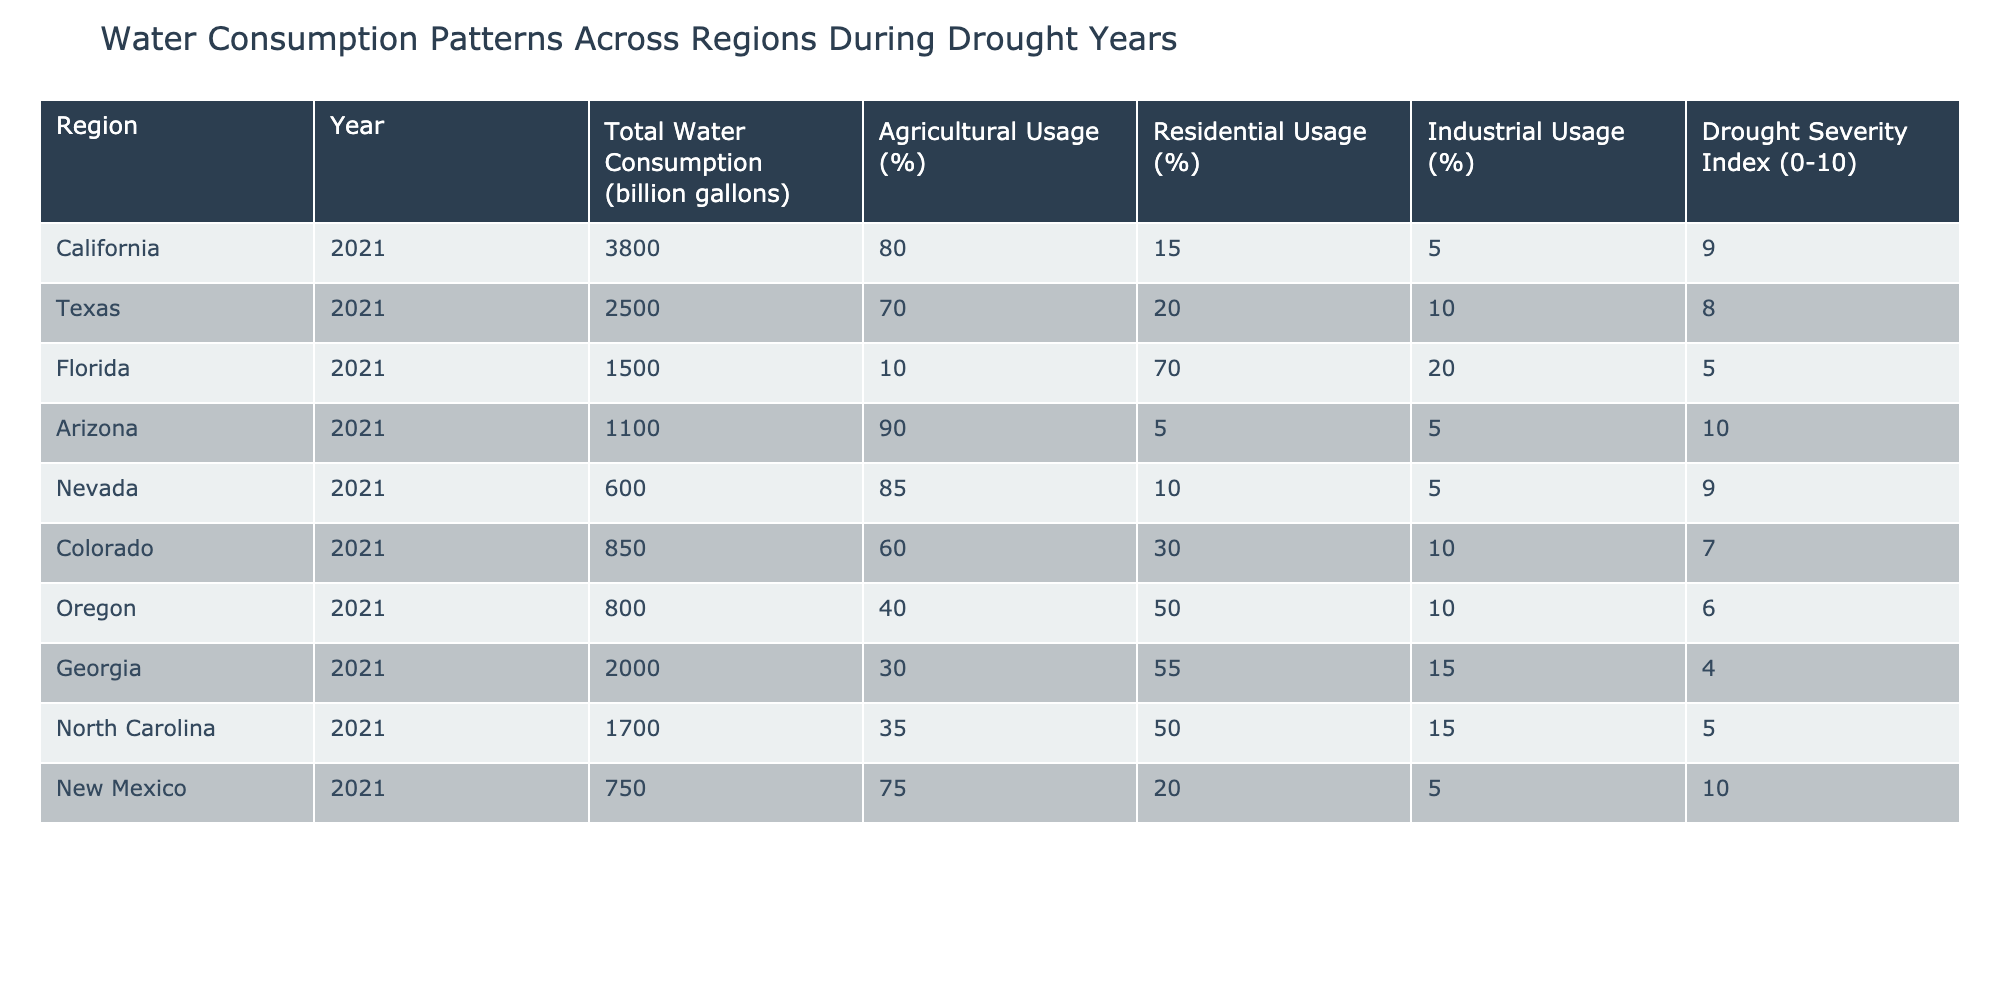What is the total water consumption for California in 2021? The table shows that California's total water consumption in 2021 is listed directly under the 'Total Water Consumption' column for that region. The value is 3800 billion gallons.
Answer: 3800 billion gallons Which region has the highest agricultural usage percentage? By examining the table, Arizona has an agricultural usage percentage of 90%, which is higher than all the other regions listed.
Answer: Arizona What is the average water consumption across all the regions in 2021? To find the average, we first sum the total water consumption figures for all regions: 3800 + 2500 + 1500 + 1100 + 600 + 850 + 800 + 2000 + 1700 + 750 = 14500 billion gallons. There are 10 regions, so we divide the total by 10: 14500/10 = 1450 billion gallons.
Answer: 1450 billion gallons Is the residential water usage percentage higher in Florida than in Georgia? Checking the table, Florida's residential usage percentage is 70%, while Georgia's is 55%. Since 70% is greater than 55%, the statement is true.
Answer: Yes How many regions have a drought severity index greater than or equal to 8? The drought severity index shows 9 for California, 8 for Texas, 10 for Arizona, 9 for Nevada, and 10 for New Mexico. That’s a total of 5 regions with an index of 8 or higher.
Answer: 5 regions What is the total industrial usage percentage in New Mexico and Texas combined? For Texas, the industrial usage percentage is 10%, and for New Mexico, it is 5%. To find the combined total, we will add both percentages: 10 + 5 = 15%.
Answer: 15% Which region has the lowest total water consumption and what is that amount? Looking at the table, Nevada has the lowest total water consumption at 600 billion gallons.
Answer: Nevada, 600 billion gallons Are there any regions with a drought severity index of 6 or less? The regions with a drought severity index of 6 or less are Oregon (6) and Georgia (4). Hence, there are indeed regions that fit this criteria.
Answer: Yes What percentage of the total water consumption in Arizona is used for agricultural purposes? Arizona's total water consumption is 1100 billion gallons, and agricultural usage is 90%. To find the amount used for agriculture, we calculate: 1100 * (90/100) = 990 billion gallons.
Answer: 990 billion gallons 